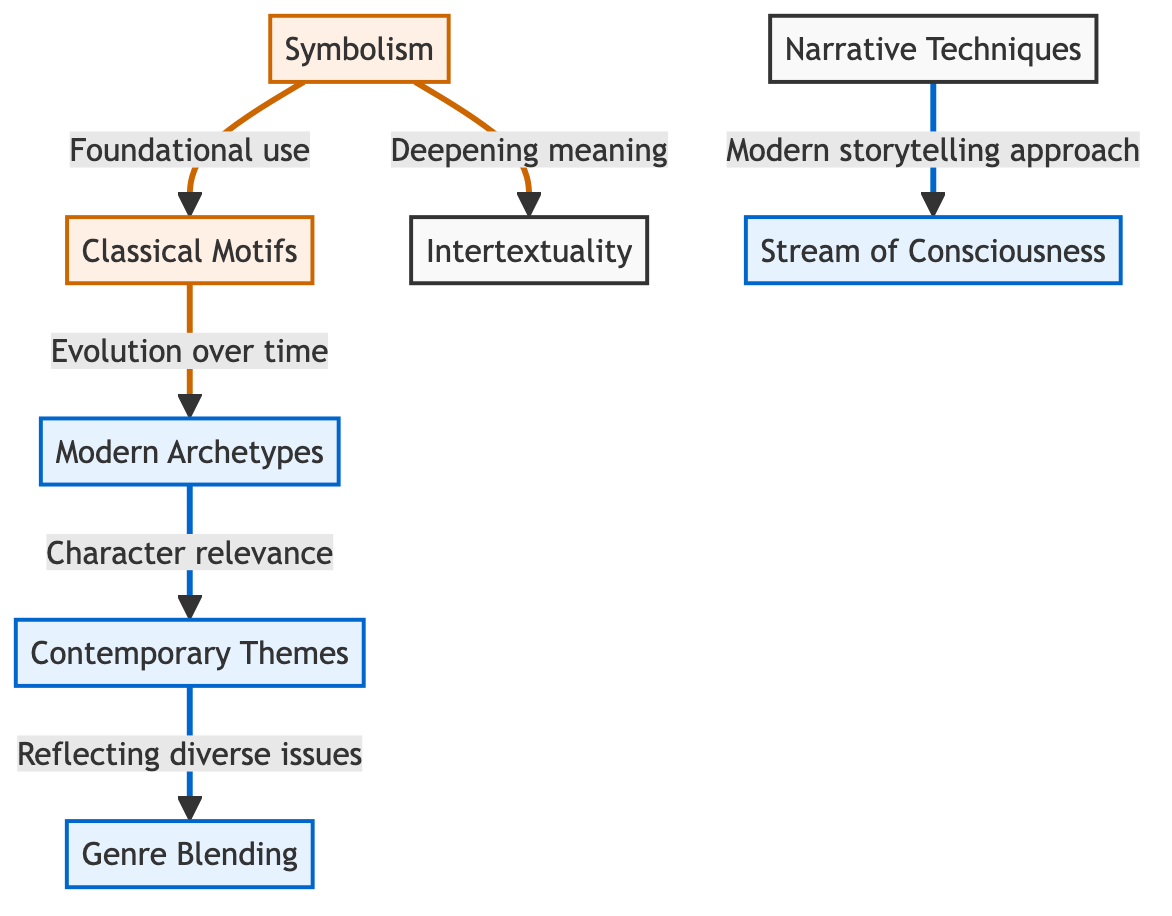What are the two main categories of literary devices shown in the diagram? The diagram displays two main categories: Classical Motifs and Modern Archetypes, which are represented by nodes at the top of the diagram.
Answer: Classical Motifs and Modern Archetypes How many narrative techniques are represented in the diagram? There is one node labeled "Narrative Techniques," and it connects to the modern storytelling approach represented by "Stream of Consciousness."
Answer: 1 What is the relationship between Classical Motifs and Modern Archetypes? The diagram uses an arrow to show that Classical Motifs evolve over time into Modern Archetypes, indicating a developmental relationship.
Answer: Evolution over time What does Symbolism deepen according to the diagram? The diagram states that Symbolism is connected to Intertextuality, indicating that it deepens meaning through this relationship.
Answer: Meaning Which modern literary device reflects diverse issues? The "Contemporary Themes" node is labeled as reflecting diverse issues, connecting it to Modern Archetypes.
Answer: Contemporary Themes What are the two connections listed for Symbolism? Symbolism has two labeled connections in the diagram: one connects it to Intertextuality and another to its foundational use with Classical Motifs.
Answer: Deepening meaning and Foundational use Which term connects "Modern Archetypes" to "Contemporary Themes"? The diagram indicates that Modern Archetypes connect to Contemporary Themes via the phrase "Character relevance," illustrating how character development adapts over time.
Answer: Character relevance How many modern literary devices are identified in the diagram? The diagram contains three distinct nodes identifying modern literary devices: Modern Archetypes, Contemporary Themes, and Stream of Consciousness.
Answer: 3 Which literary device emphasizes genre blending? The node labeled "Genre Blending" is emphasized in the diagram under Modern literary devices, showing its importance in contemporary literature.
Answer: Genre Blending Describe the flow of connections starting from Narrative Techniques. The flow begins at the "Narrative Techniques" node, which connects to "Stream of Consciousness," illustrating how modern storytelling approaches influence this technique. This indicates a direct relationship between narrative structure and style.
Answer: Modern storytelling approach 